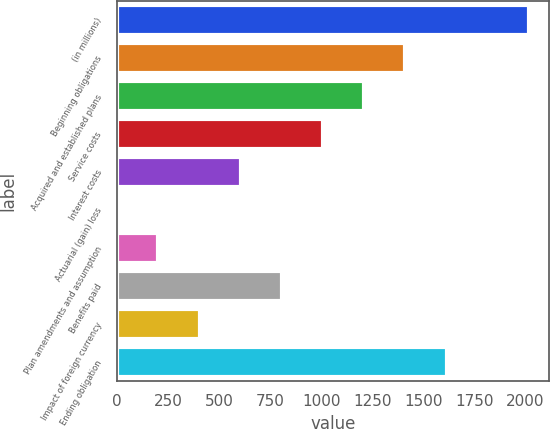<chart> <loc_0><loc_0><loc_500><loc_500><bar_chart><fcel>(in millions)<fcel>Beginning obligations<fcel>Acquired and established plans<fcel>Service costs<fcel>Interest costs<fcel>Actuarial (gain) loss<fcel>Plan amendments and assumption<fcel>Benefits paid<fcel>Impact of foreign currency<fcel>Ending obligation<nl><fcel>2018<fcel>1412.9<fcel>1211.2<fcel>1009.5<fcel>606.1<fcel>1<fcel>202.7<fcel>807.8<fcel>404.4<fcel>1614.6<nl></chart> 